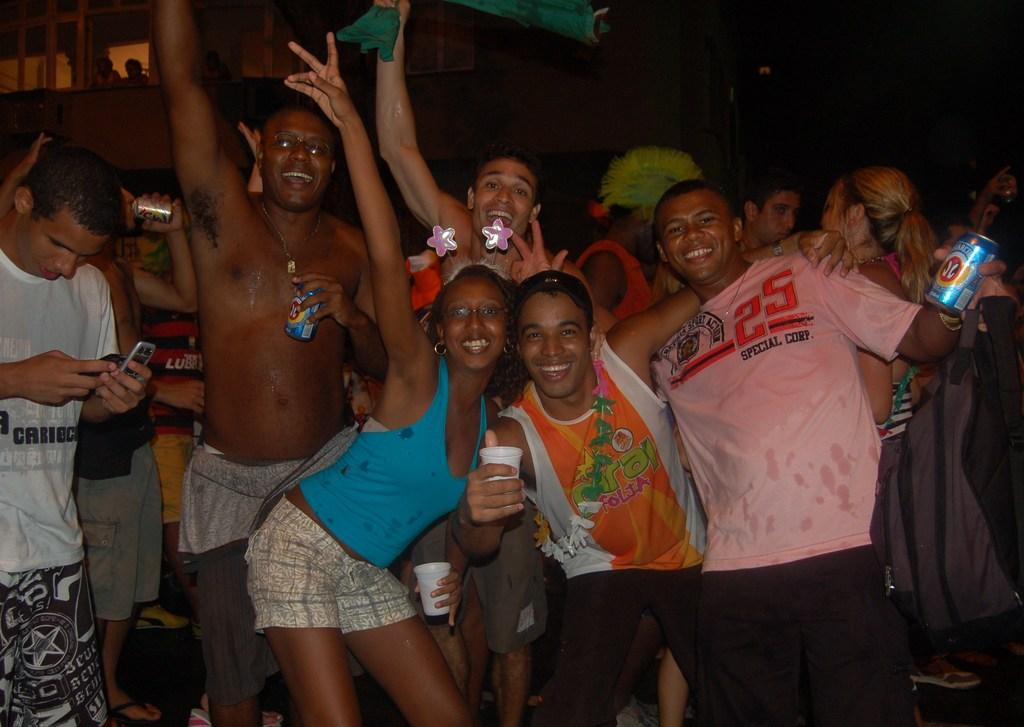How many people are in the image? There are people in the image, but the exact number is not specified. What are the people doing in the image? The people are standing and holding glasses, bottles, and tins. What expressions do the people have in the image? The people are smiling in the image. Can you tell me how many lizards are sitting on the people's shoulders in the image? There are no lizards present in the image. What type of interest does the image depict? The image does not depict any specific interest or activity. --- Facts: 1. There is a car in the image. 2. The car is red. 3. The car has four wheels. 4. The car has a license plate. 5. The car has a sunroof. Absurd Topics: parrot, sandcastle, ocean Conversation: What is the main subject of the image? The main subject of the image is a car. What color is the car? The car is red. How many wheels does the car have? The car has four wheels. What feature is present on the car? The car has a license plate and a sunroof. Reasoning: Let's think step by step in order to produce the conversation. We start by identifying the main subject of the image, which is the car. Then, we describe specific features of the car, such as its color, the number of wheels, and the presence of a license plate and a sunroof. Absurd Question/Answer: Can you tell me how many parrots are sitting on the car's roof in the image? There are no parrots present on the car's roof in the image. What type of ocean can be seen in the background of the image? There is no ocean visible in the background of the image. --- Facts: 1. There is a dog in the image. 2. The dog is sitting. 3. The dog is wearing a collar. 4. The dog has a leash attached to the collar. 5. There is a person holding the leash. Absurd Topics: piano, fireworks, bicycle Conversation: What type of animal is in the image? There is a dog in the image. What is the dog doing in the image? The dog is sitting in the image. What is the dog wearing in the image? The dog is wearing a collar in the image. What is attached to the dog's collar? The dog has a leash attached to the collar. Who is holding the leash in the image? There is a person holding the leash in the image. Reasoning: Let's think step by step in order to produce the conversation. We start by identifying the main subject of the image, which is the dog. Then, we describe the dog's actions and appearance, noting that it is sitting 